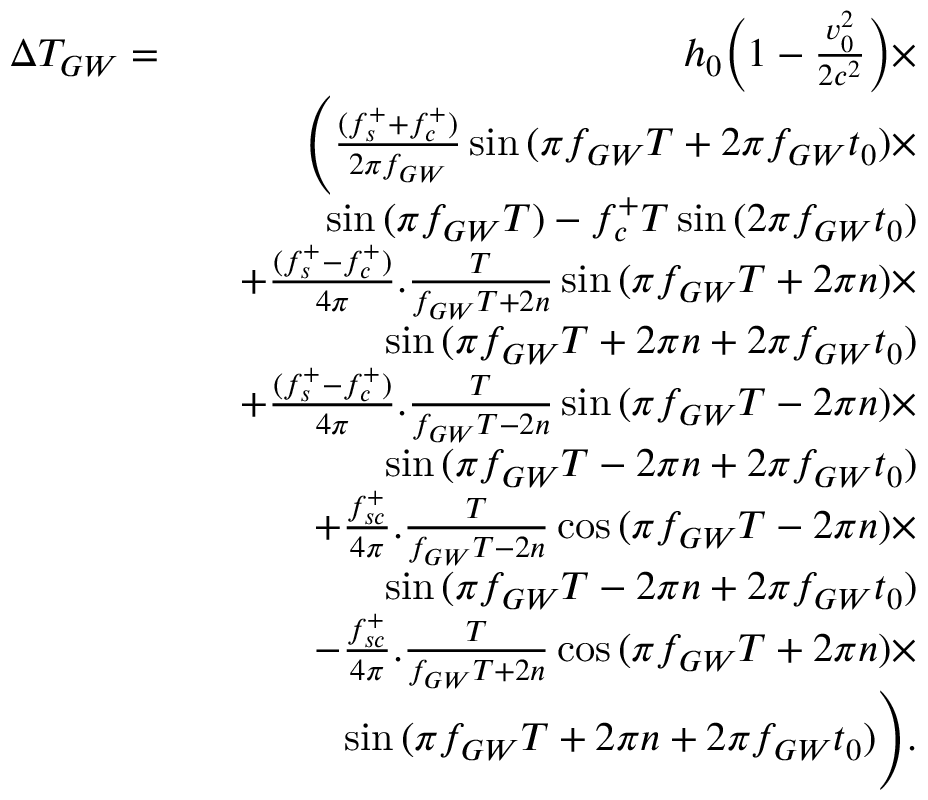Convert formula to latex. <formula><loc_0><loc_0><loc_500><loc_500>\begin{array} { r l r } { \Delta T _ { G W } = } & { h _ { 0 } \left ( 1 - \frac { v _ { 0 } ^ { 2 } } { 2 c ^ { 2 } } \right ) \times } \\ & { \left ( \frac { ( f _ { s } ^ { + } + f _ { c } ^ { + } ) } { 2 \pi f _ { G W } } \sin { ( \pi f _ { G W } T + 2 \pi f _ { G W } t _ { 0 } ) } \times } \\ & { \sin { ( \pi f _ { G W } T ) } - f _ { c } ^ { + } T \sin { ( 2 \pi f _ { G W } t _ { 0 } ) } } \\ & { + \frac { ( f _ { s } ^ { + } - f _ { c } ^ { + } ) } { 4 \pi } . \frac { T } { f _ { G W } T + 2 n } \sin { ( \pi f _ { G W } T + 2 \pi n ) } \times } \\ & { \sin { ( \pi f _ { G W } T + 2 \pi n + 2 \pi f _ { G W } t _ { 0 } ) } } \\ & { + \frac { ( f _ { s } ^ { + } - f _ { c } ^ { + } ) } { 4 \pi } . \frac { T } { f _ { G W } T - 2 n } \sin { ( \pi f _ { G W } T - 2 \pi n ) } \times } \\ & { \sin { ( \pi f _ { G W } T - 2 \pi n + 2 \pi f _ { G W } t _ { 0 } ) } } \\ & { + \frac { f _ { s c } ^ { + } } { 4 \pi } . \frac { T } { f _ { G W } T - 2 n } \cos { ( \pi f _ { G W } T - 2 \pi n ) } \times } \\ & { \sin { ( \pi f _ { G W } T - 2 \pi n + 2 \pi f _ { G W } t _ { 0 } ) } } \\ & { - \frac { f _ { s c } ^ { + } } { 4 \pi } . \frac { T } { f _ { G W } T + 2 n } \cos { ( \pi f _ { G W } T + 2 \pi n ) } \times } \\ & { \sin { ( \pi f _ { G W } T + 2 \pi n + 2 \pi f _ { G W } t _ { 0 } ) } \right ) . } \end{array}</formula> 